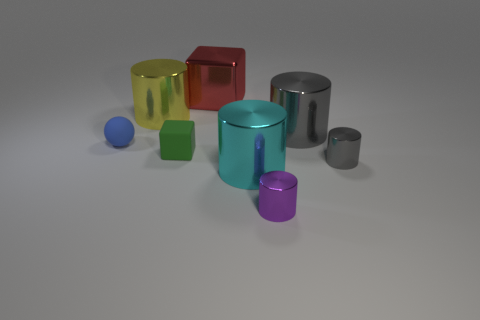Subtract all purple cylinders. How many cylinders are left? 4 Subtract 2 cylinders. How many cylinders are left? 3 Subtract all yellow cylinders. How many cylinders are left? 4 Subtract all brown cylinders. Subtract all green balls. How many cylinders are left? 5 Add 2 tiny rubber cubes. How many objects exist? 10 Subtract all balls. How many objects are left? 7 Add 5 big yellow cylinders. How many big yellow cylinders exist? 6 Subtract 0 purple blocks. How many objects are left? 8 Subtract all red shiny cylinders. Subtract all yellow shiny things. How many objects are left? 7 Add 8 yellow objects. How many yellow objects are left? 9 